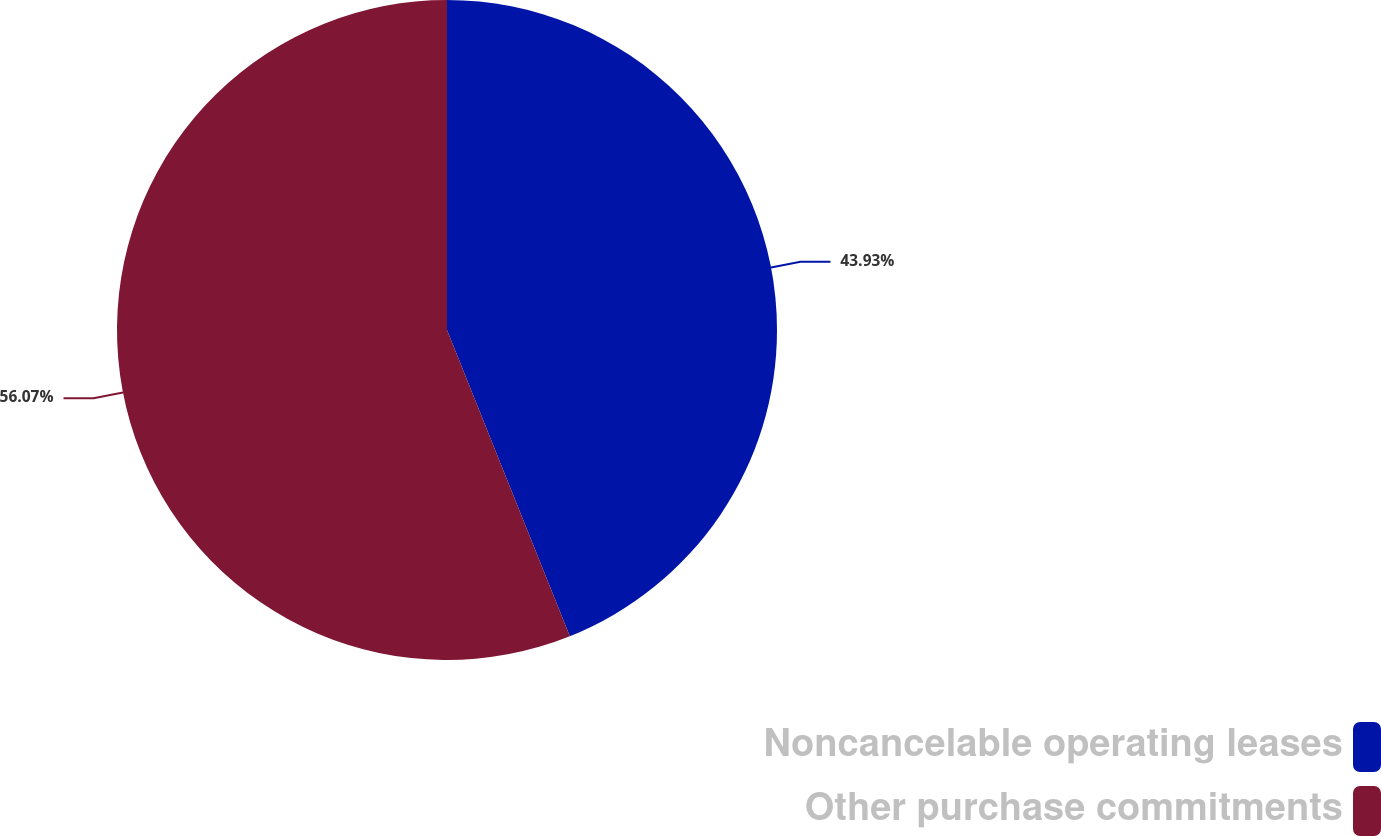Convert chart to OTSL. <chart><loc_0><loc_0><loc_500><loc_500><pie_chart><fcel>Noncancelable operating leases<fcel>Other purchase commitments<nl><fcel>43.93%<fcel>56.07%<nl></chart> 